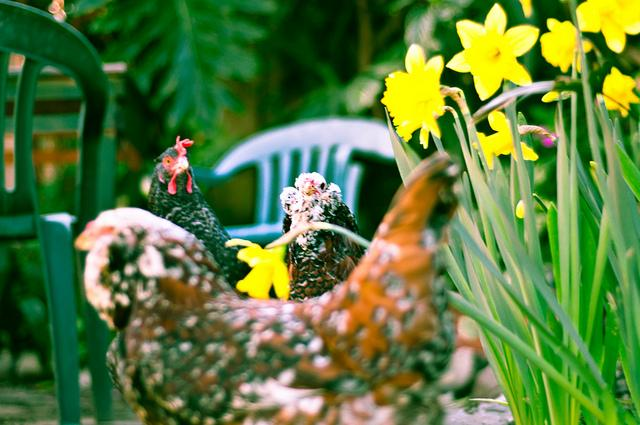What animal is near the flowers?

Choices:
A) dog
B) rooster
C) cat
D) cow rooster 